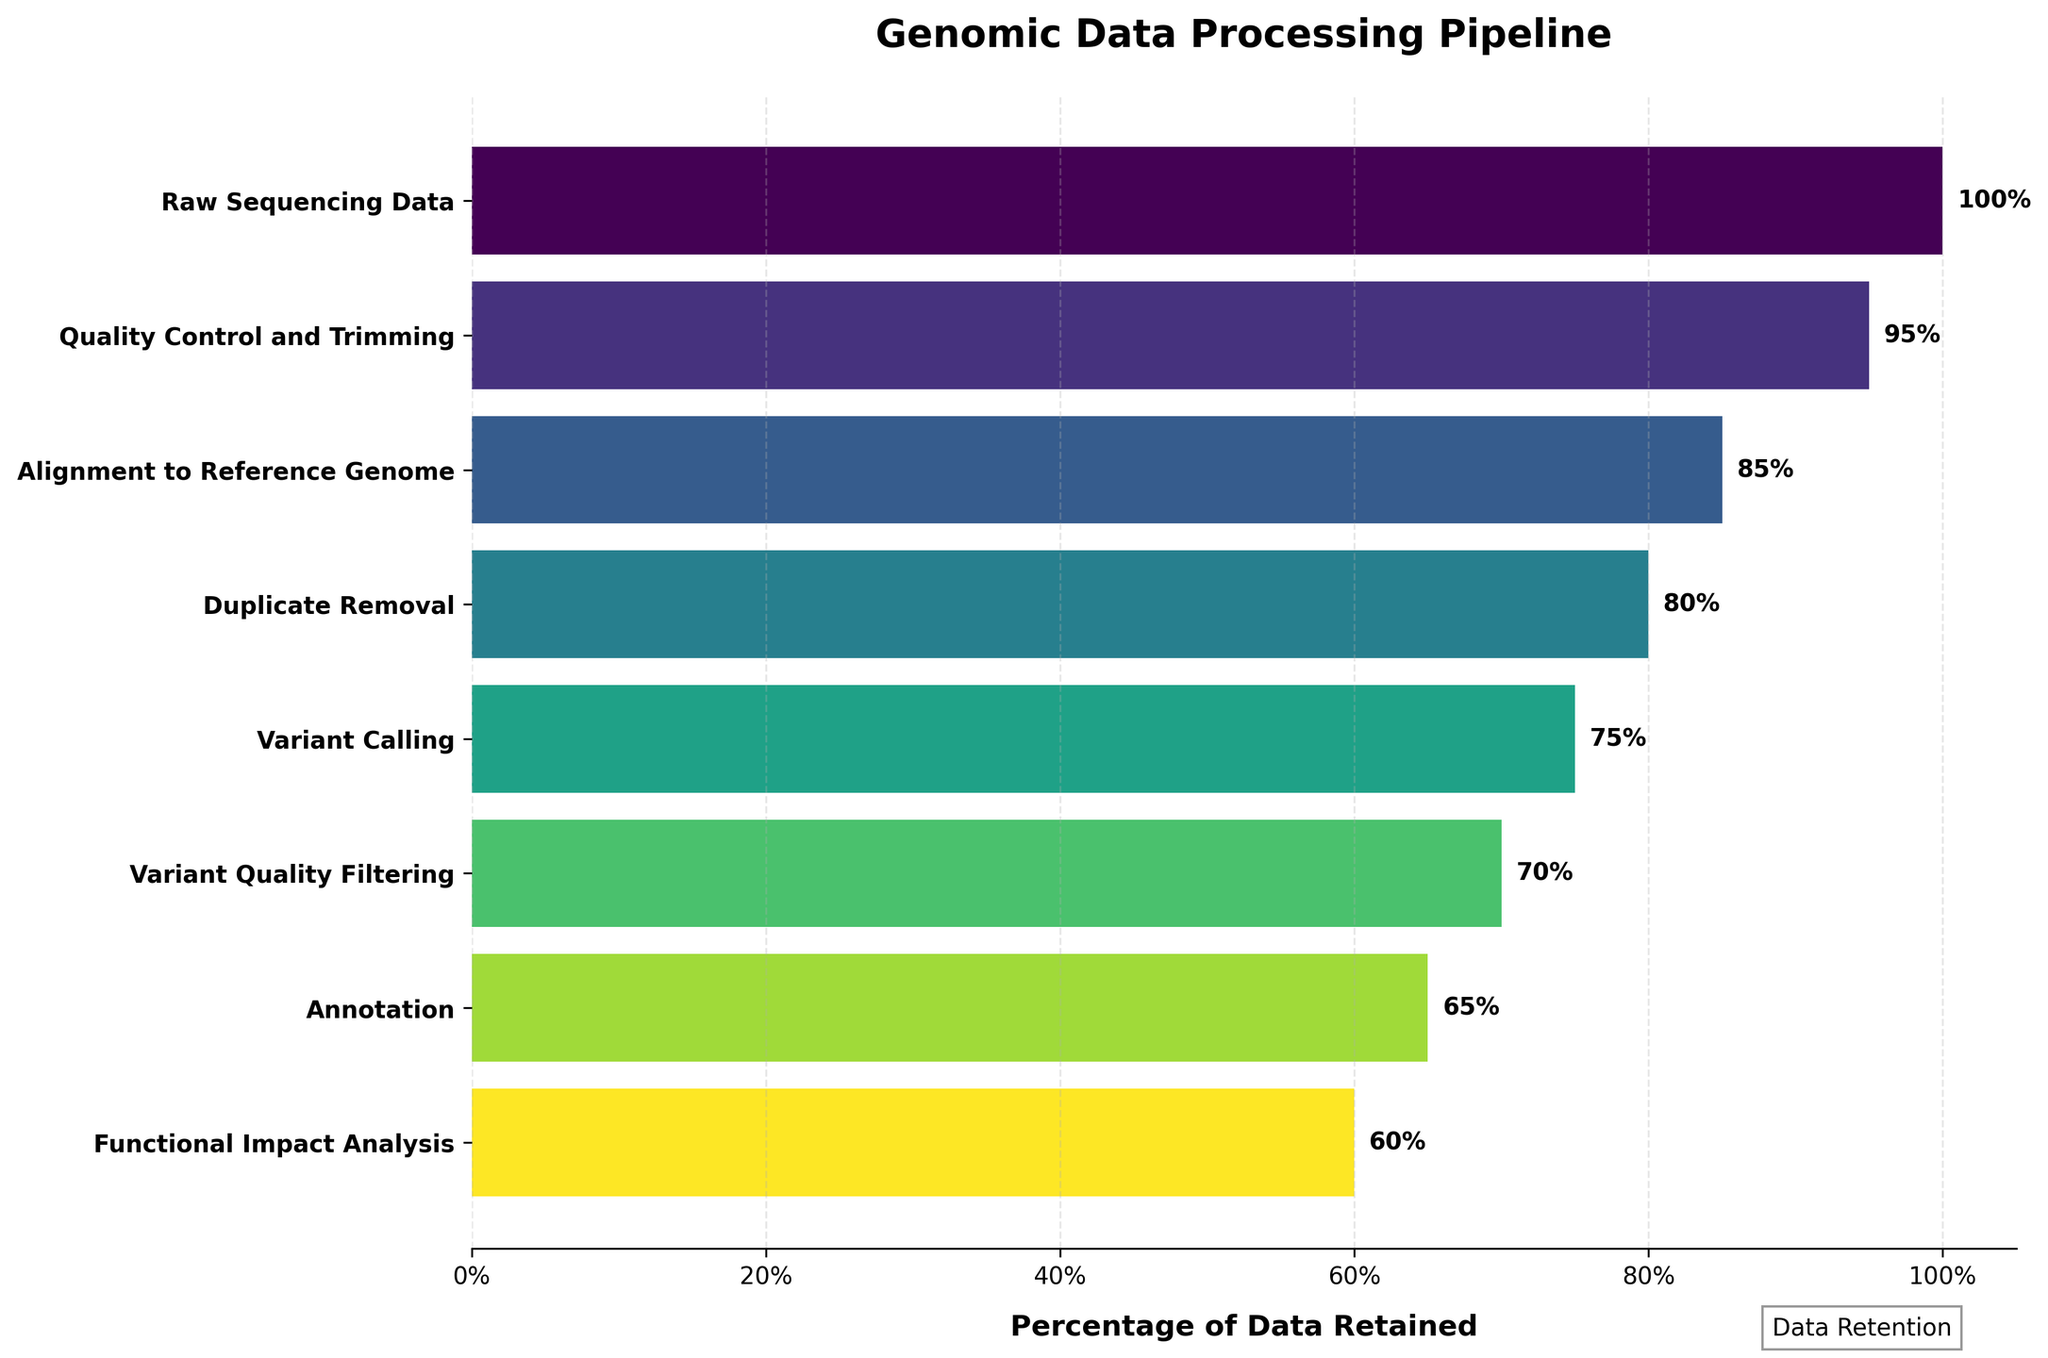What's the title of the figure? The title is located at the top of the figure, usually in larger and bold font. It’s intended to provide a summary of what the figure is about. In this case, the title is "Genomic Data Processing Pipeline".
Answer: Genomic Data Processing Pipeline What percentage of data is retained after the Quality Control and Trimming stage? The figure lists the percentages retained at each stage next to the stage name. For the Quality Control and Trimming stage, the percentage is shown as 95%.
Answer: 95% How many stages does the genomic data processing pipeline have? Each stage is listed on the vertical axis of the figure. Counting these stages gives the total number. Starting from "Raw Sequencing Data" to "Functional Impact Analysis", there are 8 stages.
Answer: 8 Which stage has the greatest data loss compared to the previous stage? To find the greatest data loss, calculate the difference in percentages between successive stages. The stage with the largest difference is identified. For example, the largest drop is between "Alignment to Reference Genome" (85%) and "Duplicate Removal" (80%), which is a 5% reduction.
Answer: Alignment to Reference Genome to Duplicate Removal What percentage of data is retained by the end of the pipeline? The final value in the figure indicates the percentage of data retained at the last stage. This is shown next to the "Functional Impact Analysis" stage, indicating 60%.
Answer: 60% Which stage retains only 75% of the data? The figure shows the retained percentages for each stage. For 75%, this percentage is listed next to "Variant Calling".
Answer: Variant Calling What is the total data loss from the Raw Sequencing Data stage to the Annotation stage? Calculate the difference between the percentage of "Raw Sequencing Data" and "Annotation". Raw Sequencing Data starts at 100%, and Annotation retains 65%, leading to a total data loss of 100% - 65% = 35%.
Answer: 35% Compare the data retention between Quality Control and Trimming and Variant Quality Filtering stages. Which retains more data? Quality Control and Trimming retains 95% while Variant Quality Filtering retains 70%. Thus, Quality Control and Trimming retains more data.
Answer: Quality Control and Trimming retains more What percentage of data is lost between Duplicate Removal and Functional Impact Analysis stages? Calculate the difference between the percentages of these two stages: Duplicate Removal retains 80% and Functional Impact Analysis retains 60%. The data loss is 80% - 60% = 20%.
Answer: 20% Rank the stages from the highest to lowest data retention. Identify the percentages retained at each stage and order them from highest to lowest. The data retention percentages are: 100%, 95%, 85%, 80%, 75%, 70%, 65%, 60%. Therefore, the ranking is: Raw Sequencing Data, Quality Control and Trimming, Alignment to Reference Genome, Duplicate Removal, Variant Calling, Variant Quality Filtering, Annotation, Functional Impact Analysis.
Answer: Raw Sequencing Data > Quality Control and Trimming > Alignment to Reference Genome > Duplicate Removal > Variant Calling > Variant Quality Filtering > Annotation > Functional Impact Analysis 